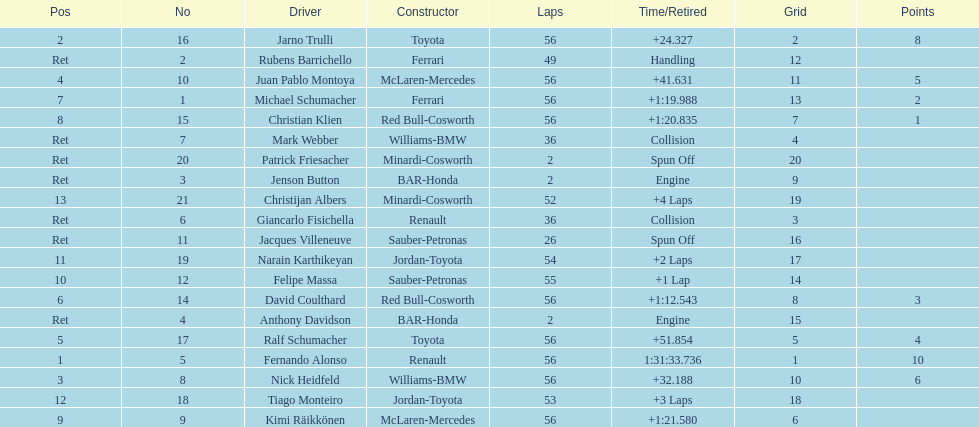How many bmws finished before webber? 1. 